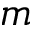Convert formula to latex. <formula><loc_0><loc_0><loc_500><loc_500>m</formula> 